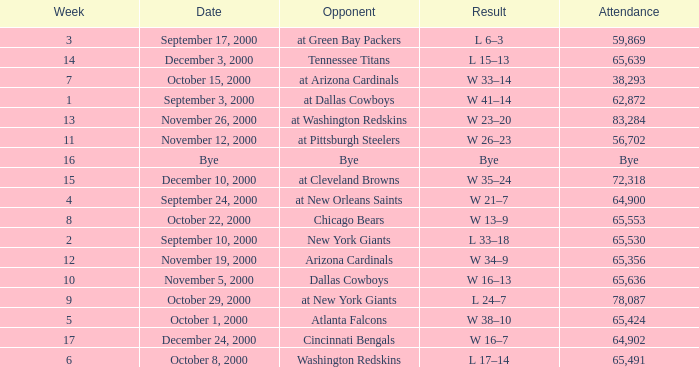What was the attendance when the Cincinnati Bengals were the opponents? 64902.0. 